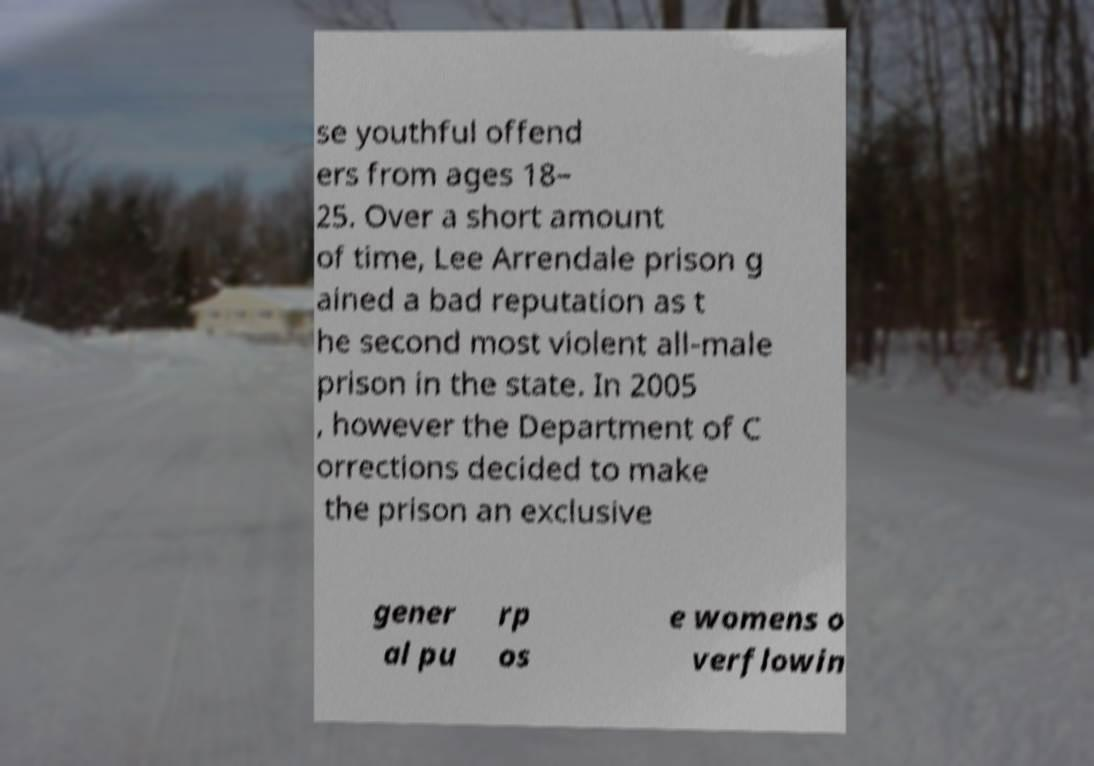Could you assist in decoding the text presented in this image and type it out clearly? se youthful offend ers from ages 18– 25. Over a short amount of time, Lee Arrendale prison g ained a bad reputation as t he second most violent all-male prison in the state. In 2005 , however the Department of C orrections decided to make the prison an exclusive gener al pu rp os e womens o verflowin 